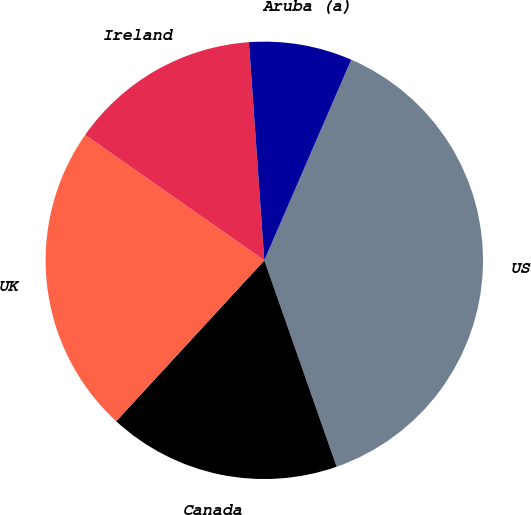<chart> <loc_0><loc_0><loc_500><loc_500><pie_chart><fcel>US<fcel>Canada<fcel>UK<fcel>Ireland<fcel>Aruba (a)<nl><fcel>38.13%<fcel>17.21%<fcel>22.88%<fcel>14.16%<fcel>7.63%<nl></chart> 